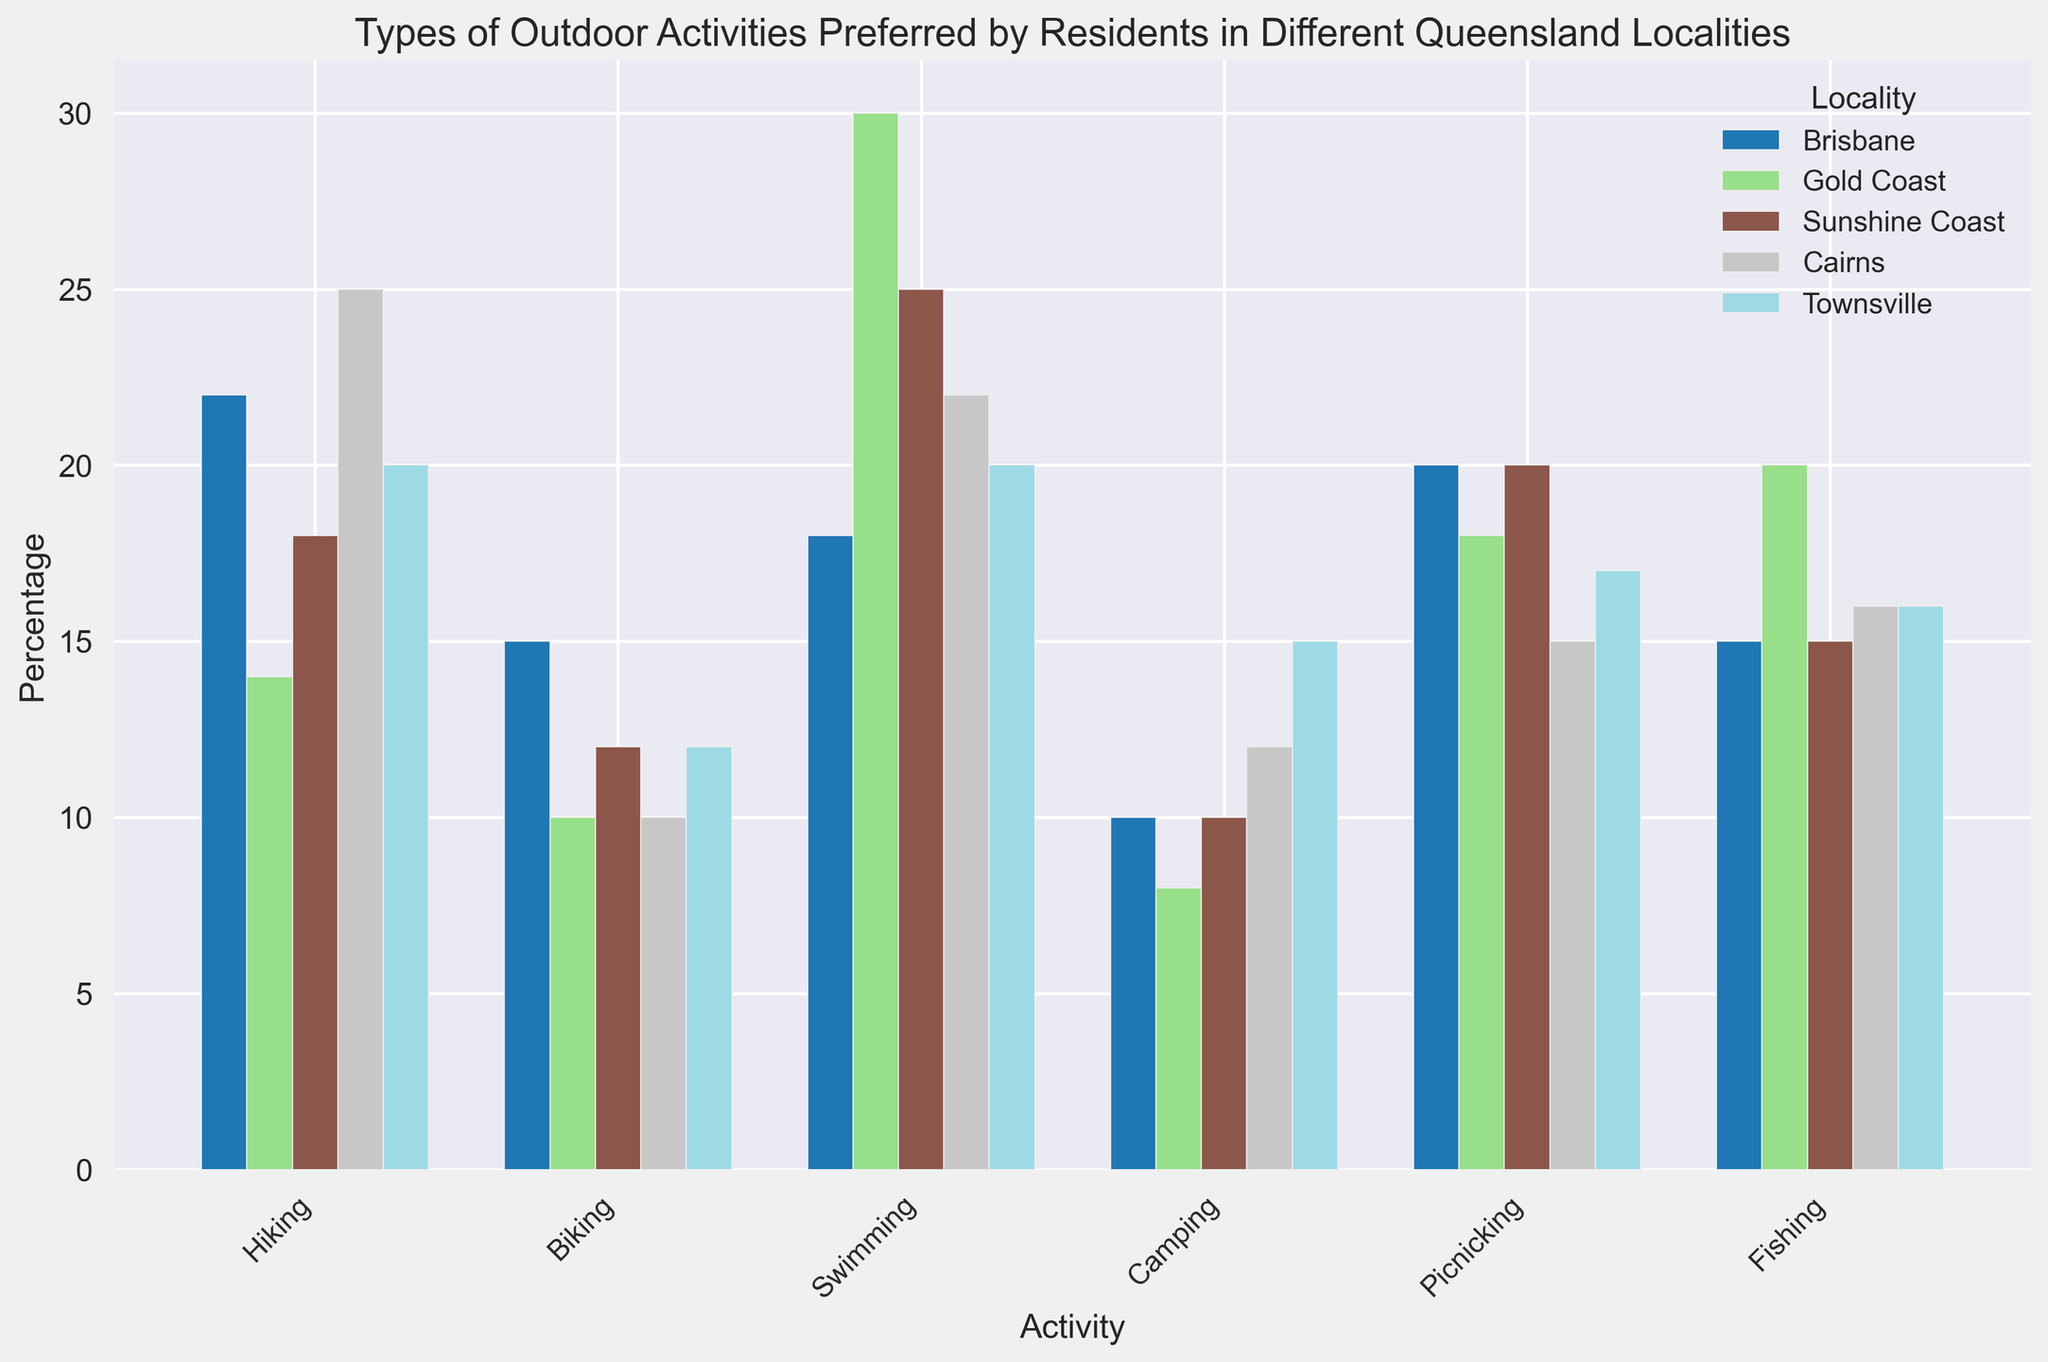Which locality prefers swimming the most? Look at the swimming bars for each locality and identify the highest one. The highest bar for swimming appears in the Gold Coast section.
Answer: Gold Coast What is the combined percentage of people preferring hiking in Brisbane and Cairns? Sum the percentages from the hiking bars for Brisbane (22%) and Cairns (25%). The combined value is 22 + 25 = 47.
Answer: 47% Which activity is equally preferred by residents of Brisbane and Townsville? Check for activities where the bar heights (percentages) are the same for Brisbane and Townsville. Camping has equal preferences in both localities with 10%.
Answer: Camping Among the localities, which one has the highest percentage of bikers? Identify the highest bar for biking among all localities. Brisbane has the highest bar with 15%.
Answer: Brisbane How does picnicking in Sunshine Coast compare to picnicking in Gold Coast? Compare the heights of the picnicking bars for Sunshine Coast and Gold Coast. Both have a percentage of 20%, so they are the same.
Answer: Same What is the average percentage of residents preferring fishing across all localities? Add up the percentages for fishing in all localities (Brisbane: 15, Gold Coast: 20, Sunshine Coast: 15, Cairns: 16, Townsville: 16), then divide by the number of localities (5). The calculation is (15 + 20 + 15 + 16 + 16) / 5 = 16.4.
Answer: 16.4% Which activity shows the highest variability in preferences across localities? Look at each activity's bars (heights) and assess which one has the most significant differences among the localities. Swimming shows the most variability with percentages ranging from 18% to 30%.
Answer: Swimming Is camping more popular in Townsville or Brisbane? Compare the heights of the camping bars for Townsville (15%) and Brisbane (10%). Townsville's camping bar is higher.
Answer: Townsville Are residents of the Gold Coast more likely to prefer fishing than those in Brisbane? Compare the fishing bar heights for Gold Coast (20%) and Brisbane (15%). Gold Coast has a higher percentage.
Answer: Yes What is the total percentage of people in Cairns who prefer either swimming or fishing? Add the percentages for swimming (22%) and fishing (16%) in Cairns. The total is 22 + 16 = 38.
Answer: 38% 